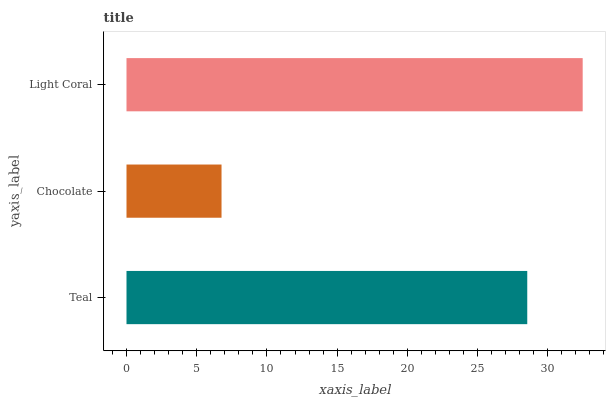Is Chocolate the minimum?
Answer yes or no. Yes. Is Light Coral the maximum?
Answer yes or no. Yes. Is Light Coral the minimum?
Answer yes or no. No. Is Chocolate the maximum?
Answer yes or no. No. Is Light Coral greater than Chocolate?
Answer yes or no. Yes. Is Chocolate less than Light Coral?
Answer yes or no. Yes. Is Chocolate greater than Light Coral?
Answer yes or no. No. Is Light Coral less than Chocolate?
Answer yes or no. No. Is Teal the high median?
Answer yes or no. Yes. Is Teal the low median?
Answer yes or no. Yes. Is Light Coral the high median?
Answer yes or no. No. Is Light Coral the low median?
Answer yes or no. No. 